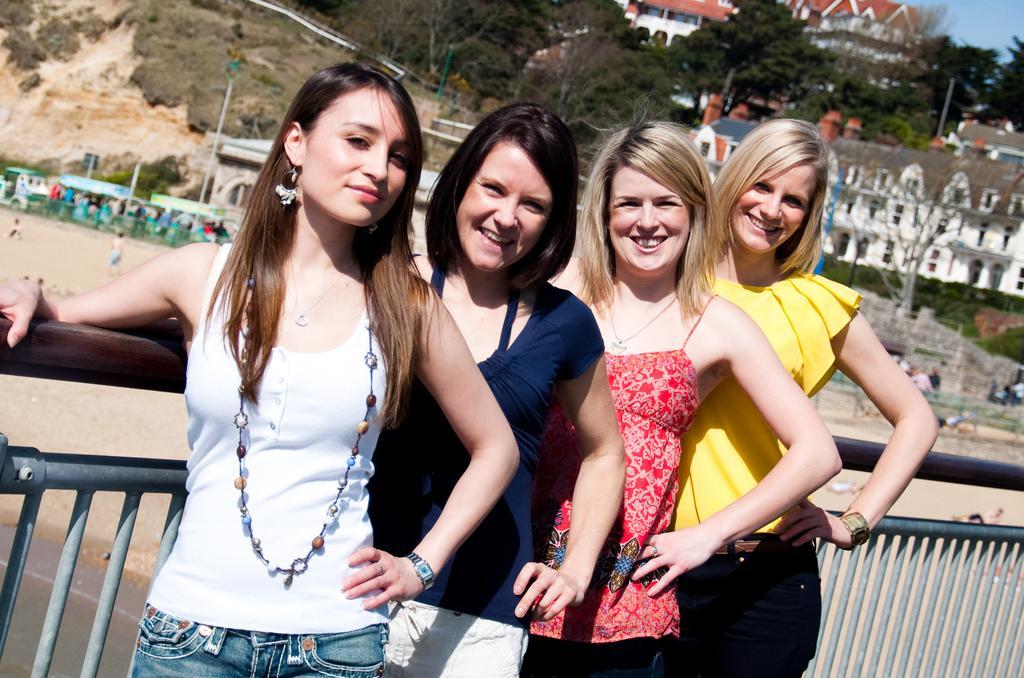Describe this image in one or two sentences. In this image there few women standing in front of fence, back side of fence there are buildings, trees, poles, hill, in the top right corner there is the sky, on the left side there are few people. 